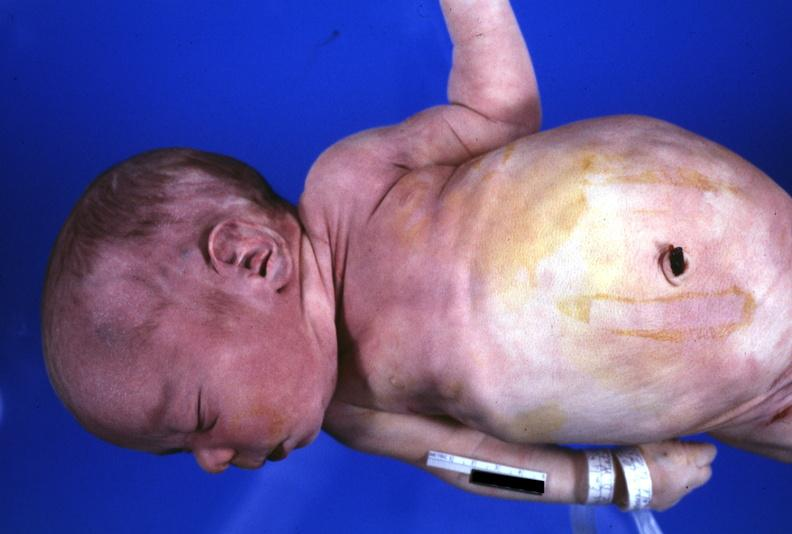s potters facies present?
Answer the question using a single word or phrase. Yes 